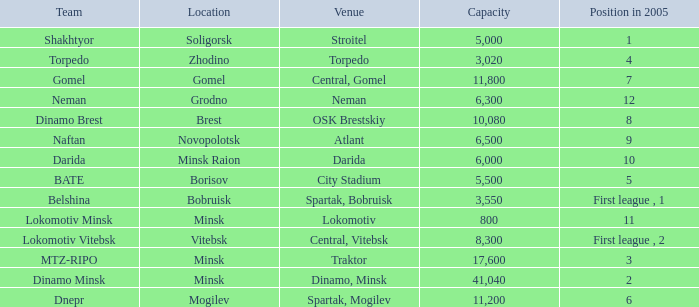In 2005, which capacity corresponds to the position of 8? 10080.0. 